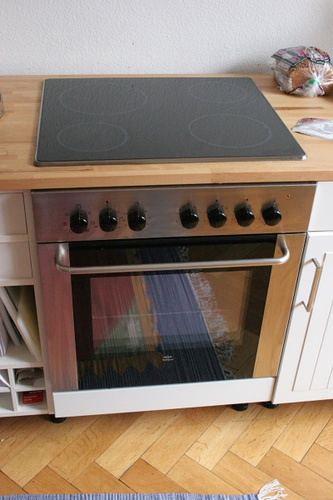Describe the objects in this image and their specific colors. I can see oven in lightgray, black, gray, brown, and maroon tones and oven in lightgray, gray, and tan tones in this image. 